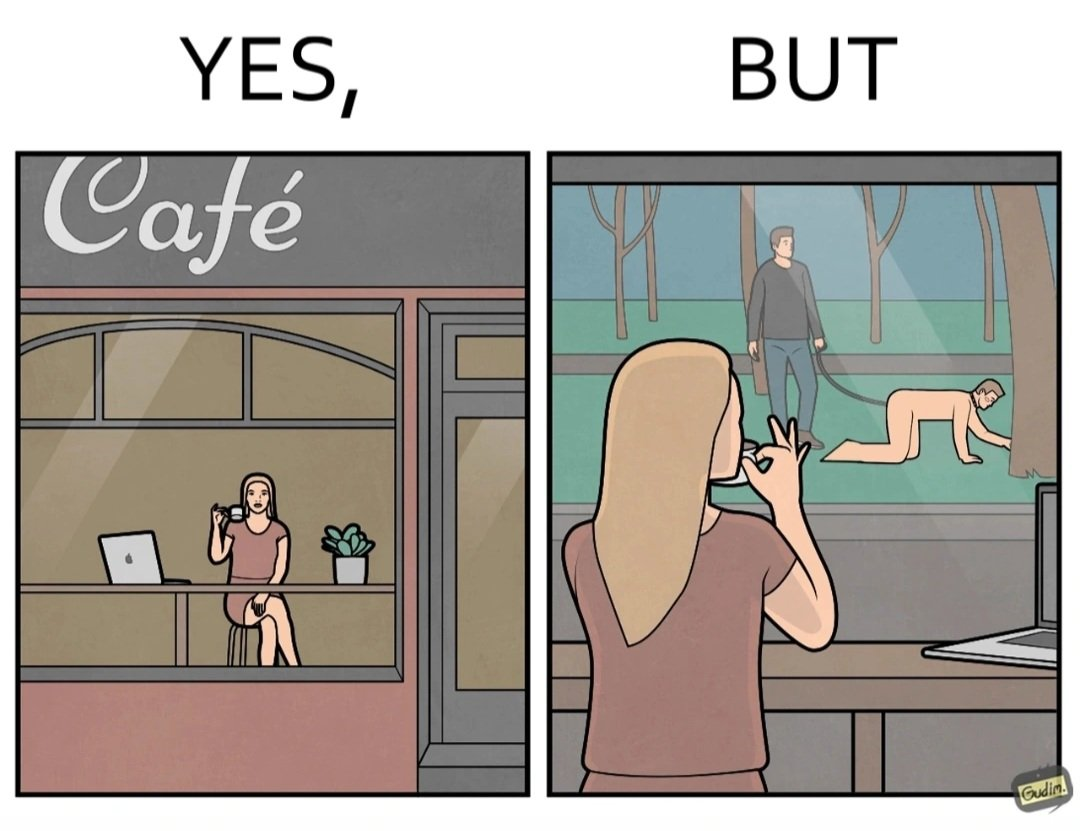What is shown in the left half versus the right half of this image? In the left part of the image: a woman inside a cafe enjoying a cup of some hot drink while doing her work on a laptop and watching outside through the window In the right part of the image: a person at some cafe, while looking at an act of slavery outside through the window 